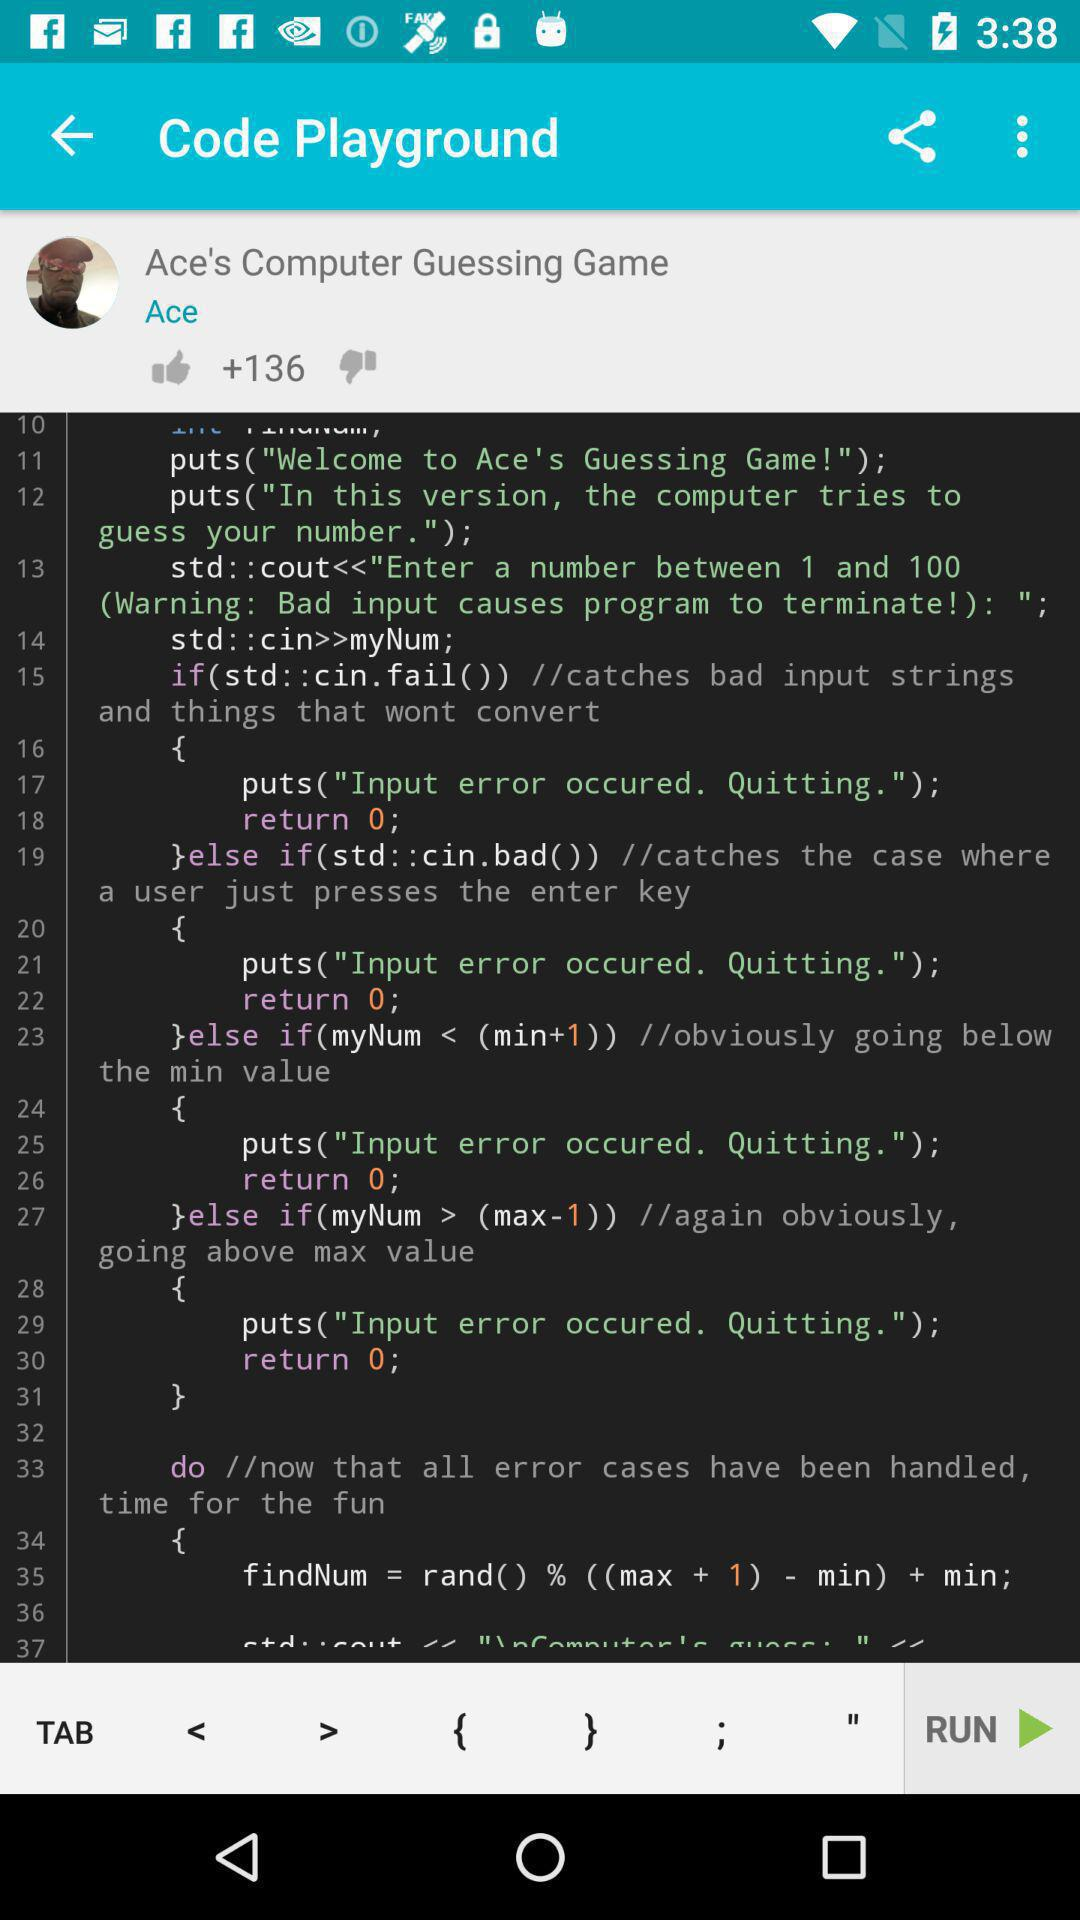How many thumbs up does the user have?
Answer the question using a single word or phrase. 136 